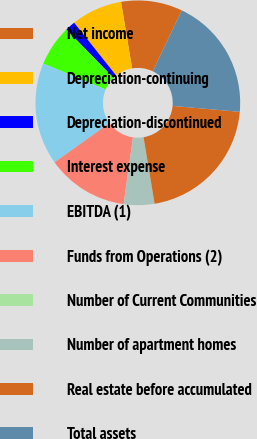<chart> <loc_0><loc_0><loc_500><loc_500><pie_chart><fcel>Net income<fcel>Depreciation-continuing<fcel>Depreciation-discontinued<fcel>Interest expense<fcel>EBITDA (1)<fcel>Funds from Operations (2)<fcel>Number of Current Communities<fcel>Number of apartment homes<fcel>Real estate before accumulated<fcel>Total assets<nl><fcel>9.68%<fcel>8.06%<fcel>1.61%<fcel>6.45%<fcel>16.13%<fcel>12.9%<fcel>0.0%<fcel>4.84%<fcel>20.97%<fcel>19.35%<nl></chart> 